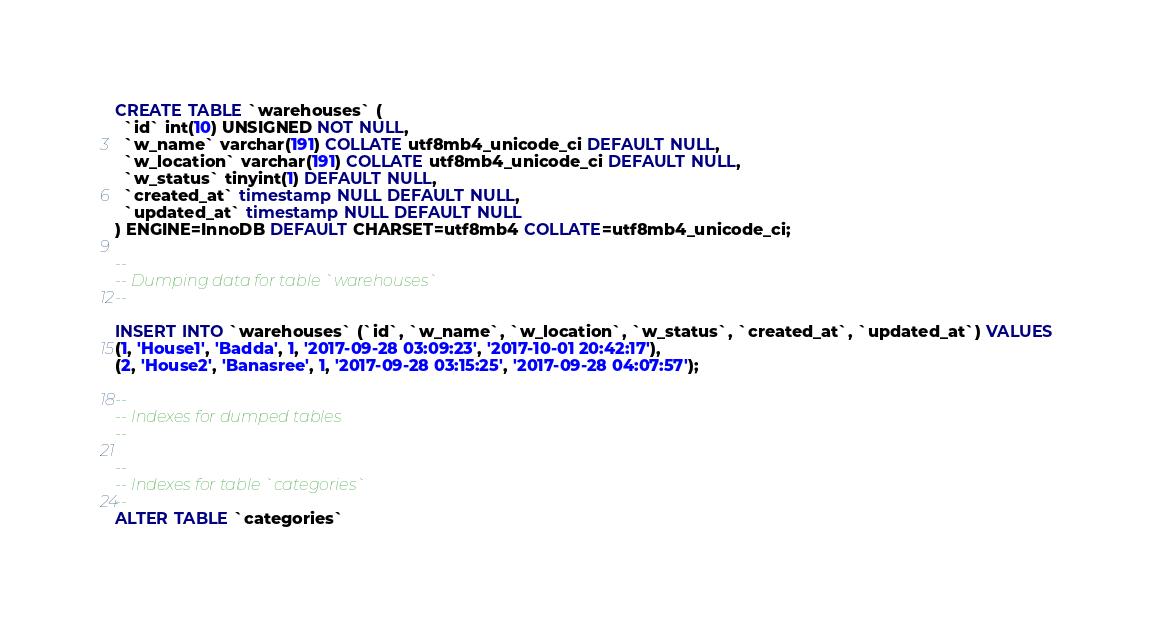Convert code to text. <code><loc_0><loc_0><loc_500><loc_500><_SQL_>
CREATE TABLE `warehouses` (
  `id` int(10) UNSIGNED NOT NULL,
  `w_name` varchar(191) COLLATE utf8mb4_unicode_ci DEFAULT NULL,
  `w_location` varchar(191) COLLATE utf8mb4_unicode_ci DEFAULT NULL,
  `w_status` tinyint(1) DEFAULT NULL,
  `created_at` timestamp NULL DEFAULT NULL,
  `updated_at` timestamp NULL DEFAULT NULL
) ENGINE=InnoDB DEFAULT CHARSET=utf8mb4 COLLATE=utf8mb4_unicode_ci;

--
-- Dumping data for table `warehouses`
--

INSERT INTO `warehouses` (`id`, `w_name`, `w_location`, `w_status`, `created_at`, `updated_at`) VALUES
(1, 'House1', 'Badda', 1, '2017-09-28 03:09:23', '2017-10-01 20:42:17'),
(2, 'House2', 'Banasree', 1, '2017-09-28 03:15:25', '2017-09-28 04:07:57');

--
-- Indexes for dumped tables
--

--
-- Indexes for table `categories`
--
ALTER TABLE `categories`</code> 